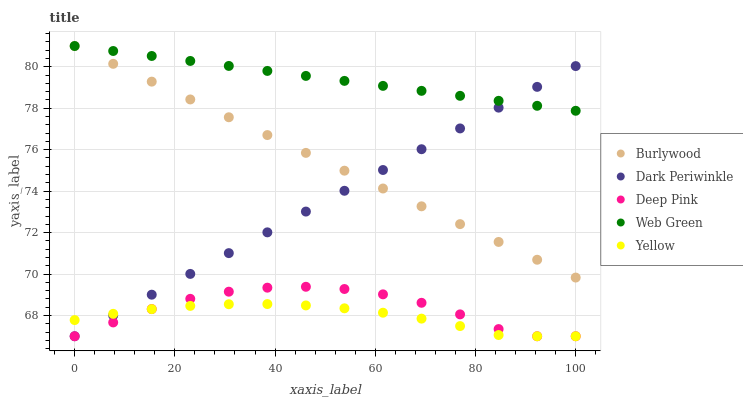Does Yellow have the minimum area under the curve?
Answer yes or no. Yes. Does Web Green have the maximum area under the curve?
Answer yes or no. Yes. Does Deep Pink have the minimum area under the curve?
Answer yes or no. No. Does Deep Pink have the maximum area under the curve?
Answer yes or no. No. Is Web Green the smoothest?
Answer yes or no. Yes. Is Deep Pink the roughest?
Answer yes or no. Yes. Is Yellow the smoothest?
Answer yes or no. No. Is Yellow the roughest?
Answer yes or no. No. Does Deep Pink have the lowest value?
Answer yes or no. Yes. Does Web Green have the lowest value?
Answer yes or no. No. Does Web Green have the highest value?
Answer yes or no. Yes. Does Deep Pink have the highest value?
Answer yes or no. No. Is Yellow less than Burlywood?
Answer yes or no. Yes. Is Burlywood greater than Yellow?
Answer yes or no. Yes. Does Dark Periwinkle intersect Burlywood?
Answer yes or no. Yes. Is Dark Periwinkle less than Burlywood?
Answer yes or no. No. Is Dark Periwinkle greater than Burlywood?
Answer yes or no. No. Does Yellow intersect Burlywood?
Answer yes or no. No. 